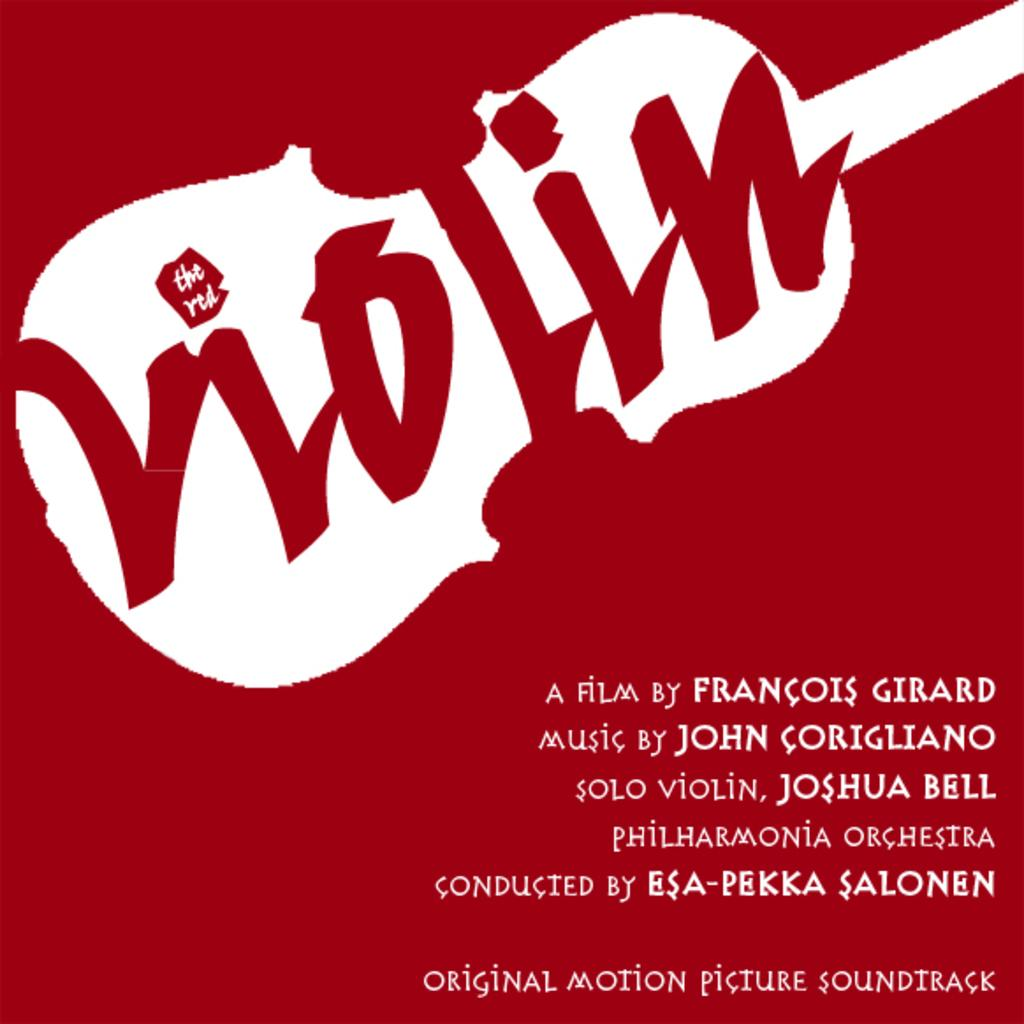Provide a one-sentence caption for the provided image. The film Violin was made by Francois Girard, according to this poster. 